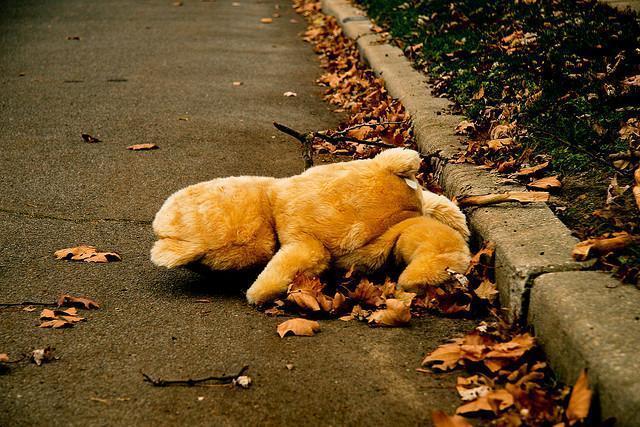How many bears are on the ground?
Give a very brief answer. 1. 